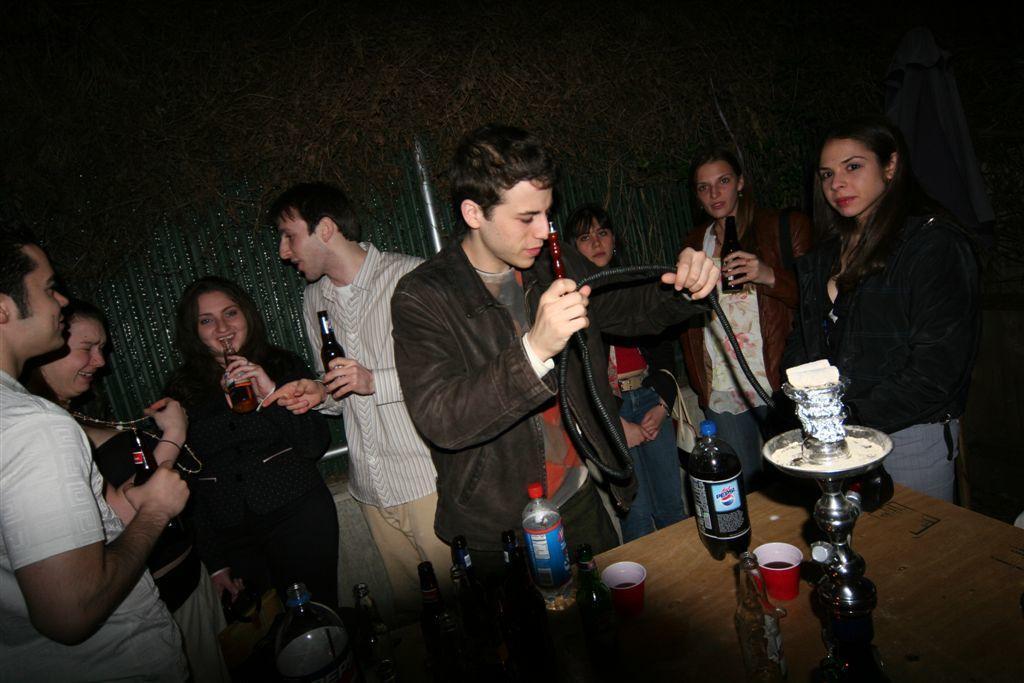In one or two sentences, can you explain what this image depicts? In this picture, we see people holding wine bottles in their hands. In front of them, we see a table on which cup, glass, water bottles, hookah machine and wine bottles are placed. This picture might be clicked in the bar. In the background, it is black in color and this picture picture is clicked in the dark. 